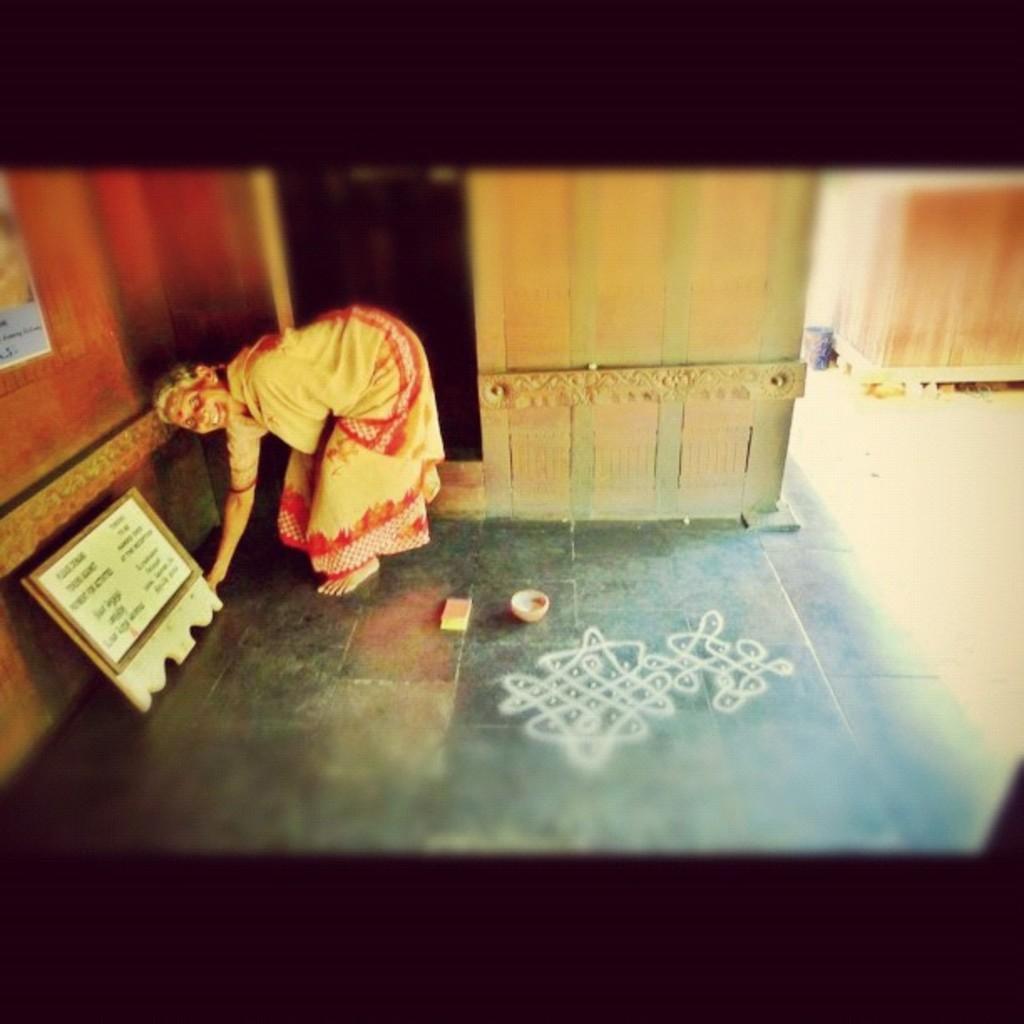Can you describe this image briefly? In this image I can see a woman bending. There is a board on the left. There is a drawing on the floor. 